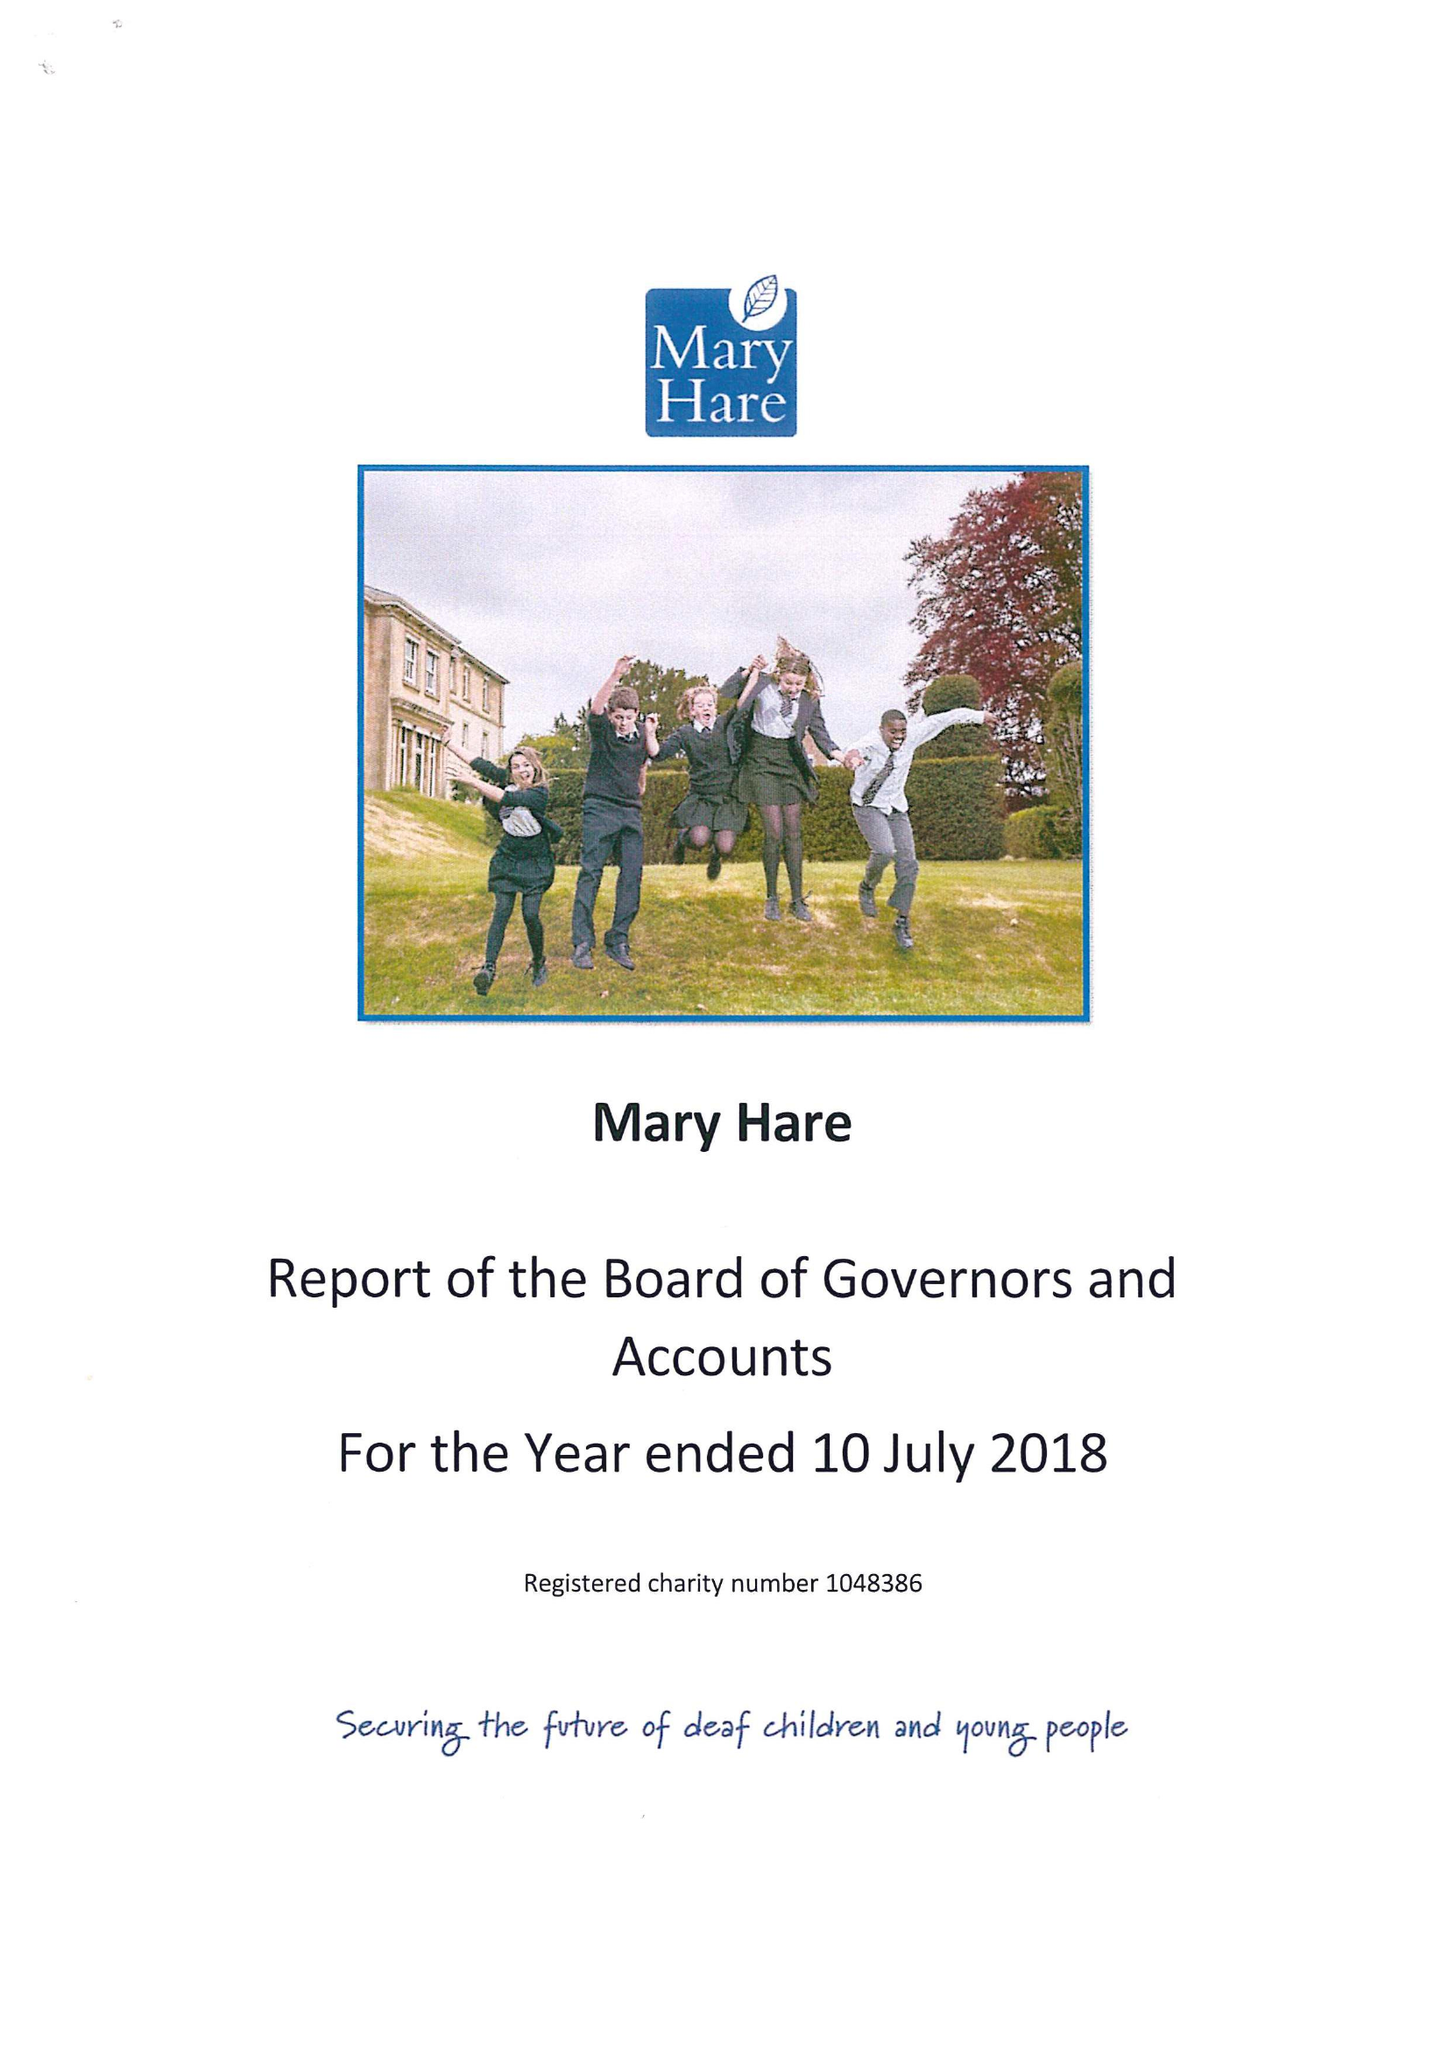What is the value for the charity_name?
Answer the question using a single word or phrase. Mary Hare 